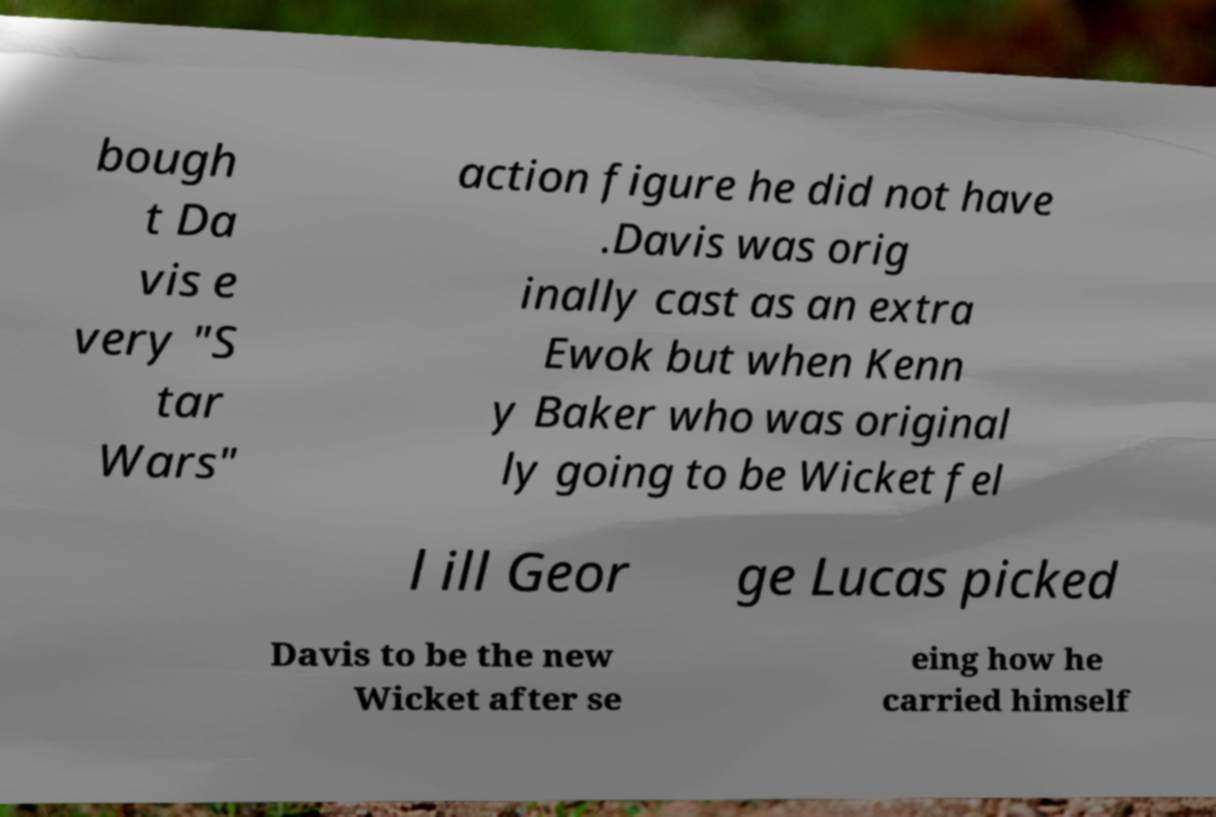Please identify and transcribe the text found in this image. bough t Da vis e very "S tar Wars" action figure he did not have .Davis was orig inally cast as an extra Ewok but when Kenn y Baker who was original ly going to be Wicket fel l ill Geor ge Lucas picked Davis to be the new Wicket after se eing how he carried himself 